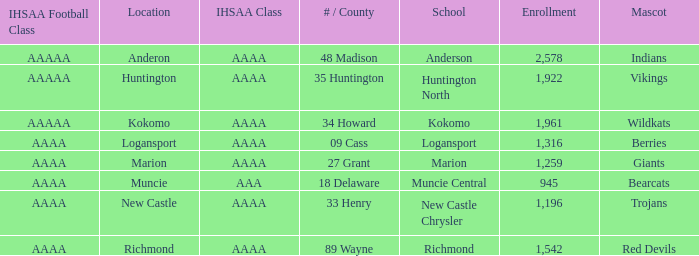What's the IHSAA class of the Red Devils? AAAA. 